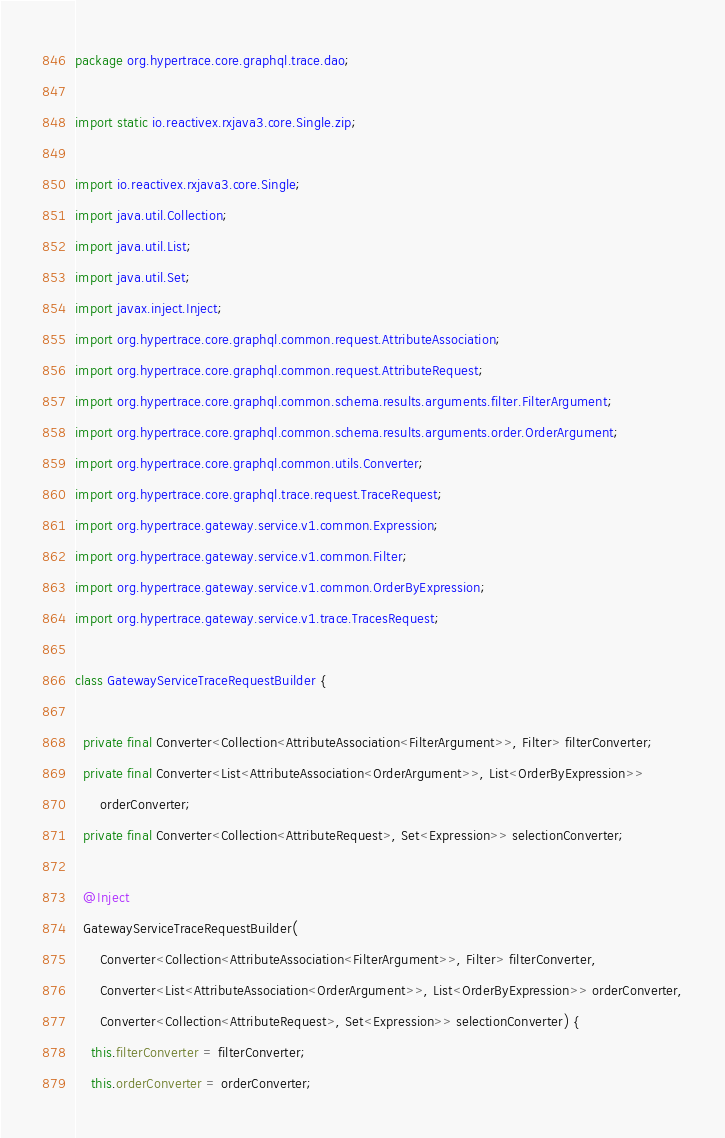<code> <loc_0><loc_0><loc_500><loc_500><_Java_>package org.hypertrace.core.graphql.trace.dao;

import static io.reactivex.rxjava3.core.Single.zip;

import io.reactivex.rxjava3.core.Single;
import java.util.Collection;
import java.util.List;
import java.util.Set;
import javax.inject.Inject;
import org.hypertrace.core.graphql.common.request.AttributeAssociation;
import org.hypertrace.core.graphql.common.request.AttributeRequest;
import org.hypertrace.core.graphql.common.schema.results.arguments.filter.FilterArgument;
import org.hypertrace.core.graphql.common.schema.results.arguments.order.OrderArgument;
import org.hypertrace.core.graphql.common.utils.Converter;
import org.hypertrace.core.graphql.trace.request.TraceRequest;
import org.hypertrace.gateway.service.v1.common.Expression;
import org.hypertrace.gateway.service.v1.common.Filter;
import org.hypertrace.gateway.service.v1.common.OrderByExpression;
import org.hypertrace.gateway.service.v1.trace.TracesRequest;

class GatewayServiceTraceRequestBuilder {

  private final Converter<Collection<AttributeAssociation<FilterArgument>>, Filter> filterConverter;
  private final Converter<List<AttributeAssociation<OrderArgument>>, List<OrderByExpression>>
      orderConverter;
  private final Converter<Collection<AttributeRequest>, Set<Expression>> selectionConverter;

  @Inject
  GatewayServiceTraceRequestBuilder(
      Converter<Collection<AttributeAssociation<FilterArgument>>, Filter> filterConverter,
      Converter<List<AttributeAssociation<OrderArgument>>, List<OrderByExpression>> orderConverter,
      Converter<Collection<AttributeRequest>, Set<Expression>> selectionConverter) {
    this.filterConverter = filterConverter;
    this.orderConverter = orderConverter;</code> 